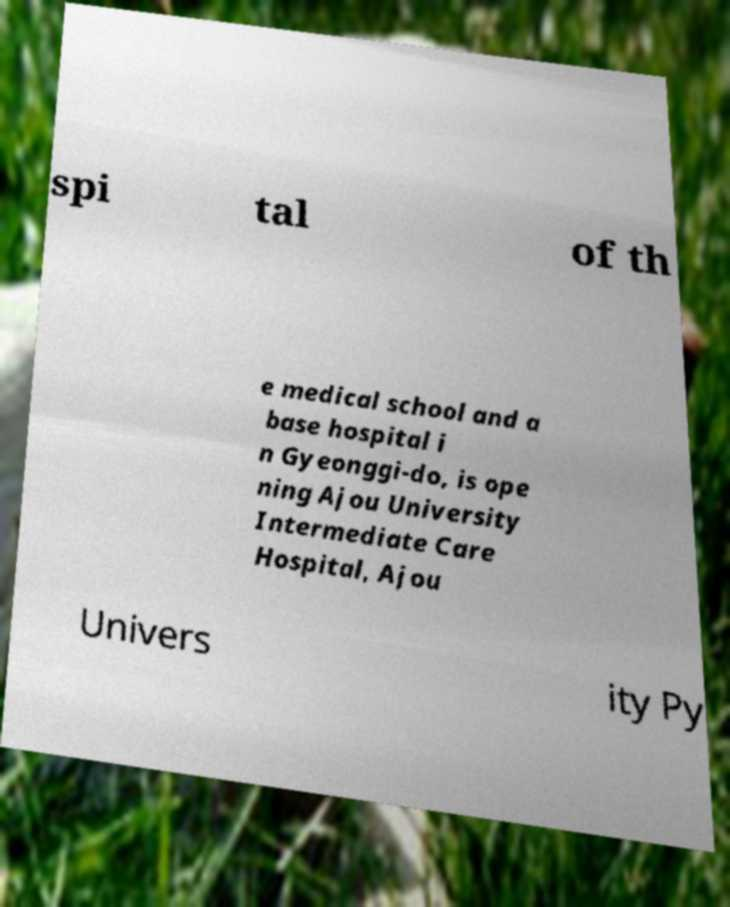Could you extract and type out the text from this image? spi tal of th e medical school and a base hospital i n Gyeonggi-do, is ope ning Ajou University Intermediate Care Hospital, Ajou Univers ity Py 